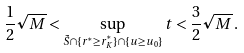<formula> <loc_0><loc_0><loc_500><loc_500>\frac { 1 } { 2 } \sqrt { M } < \sup _ { \tilde { S } \cap \{ r ^ { ^ { * } } \geq r ^ { ^ { * } } _ { K } \} \cap \{ u \geq u _ { 0 } \} } t < \frac { 3 } { 2 } \sqrt { M } \, .</formula> 